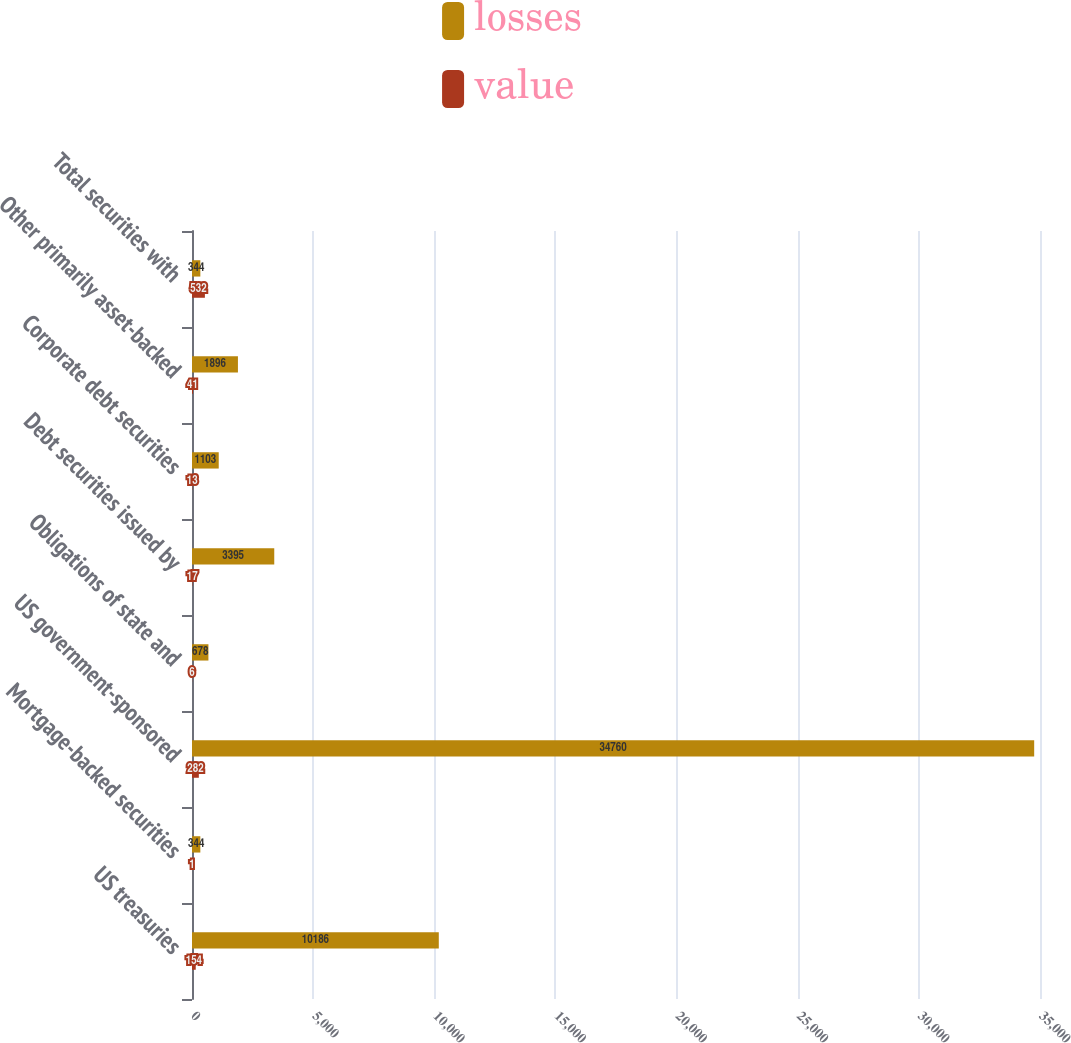Convert chart. <chart><loc_0><loc_0><loc_500><loc_500><stacked_bar_chart><ecel><fcel>US treasuries<fcel>Mortgage-backed securities<fcel>US government-sponsored<fcel>Obligations of state and<fcel>Debt securities issued by<fcel>Corporate debt securities<fcel>Other primarily asset-backed<fcel>Total securities with<nl><fcel>losses<fcel>10186<fcel>344<fcel>34760<fcel>678<fcel>3395<fcel>1103<fcel>1896<fcel>344<nl><fcel>value<fcel>154<fcel>1<fcel>282<fcel>6<fcel>17<fcel>13<fcel>41<fcel>532<nl></chart> 